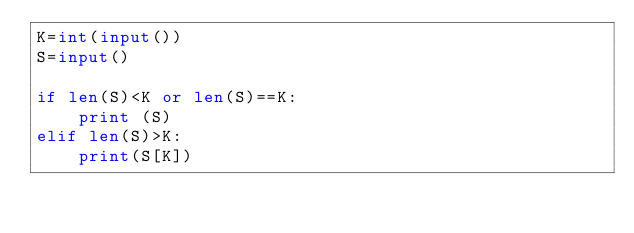Convert code to text. <code><loc_0><loc_0><loc_500><loc_500><_Python_>K=int(input())
S=input()

if len(S)<K or len(S)==K:
    print (S)
elif len(S)>K:
    print(S[K])  
</code> 